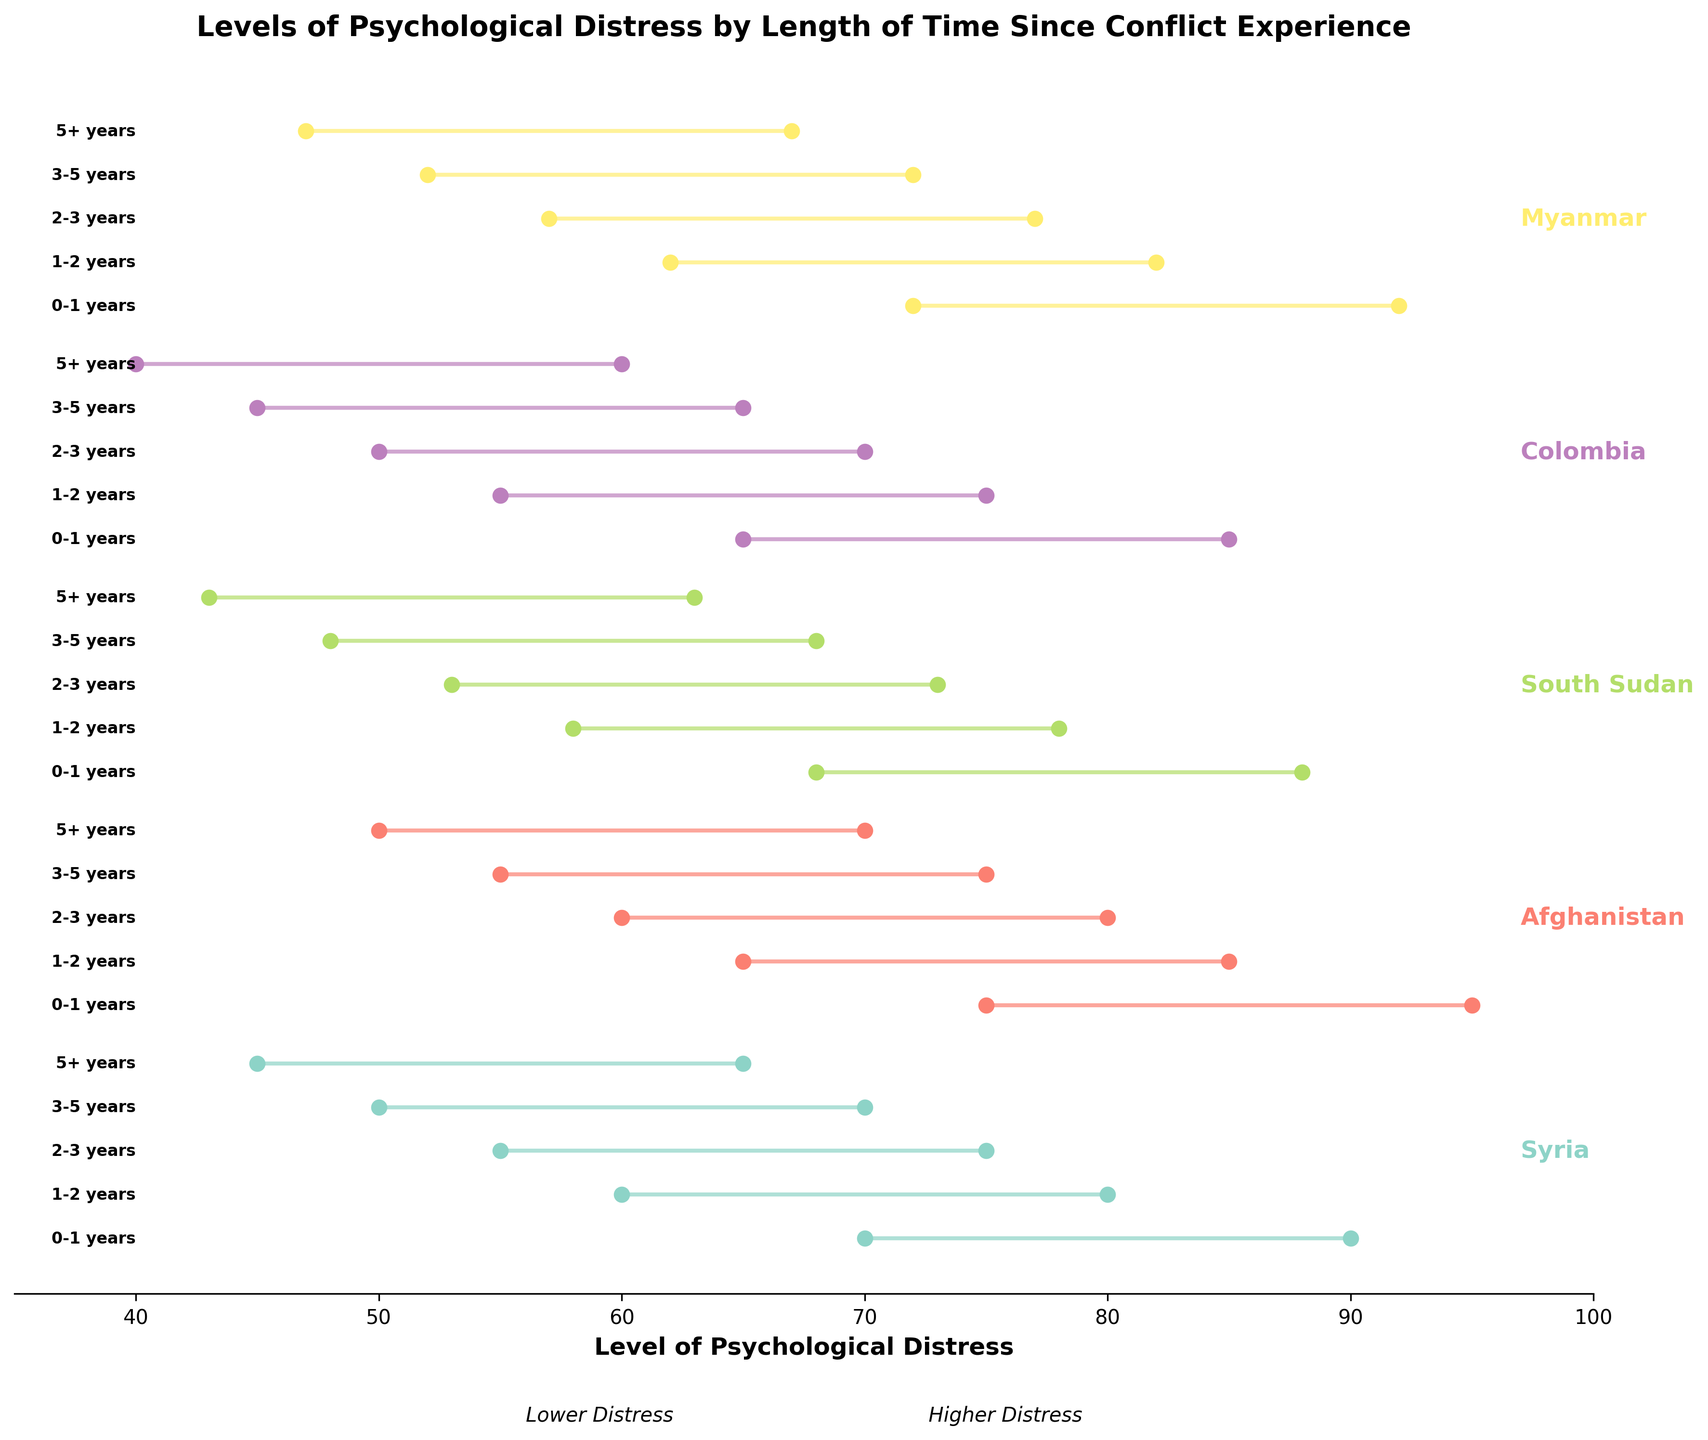Which group has the highest level of psychological distress in the first year after the conflict? In the range for the first year after the conflict, you need to evaluate the maximum distress values for all groups: Syria (90), Afghanistan (95), South Sudan (88), Colombia (85), and Myanmar (92). The highest maximum distress value is for Afghanistan.
Answer: Afghanistan How does the minimum level of psychological distress in Syria change from 0-1 years to 5+ years after the conflict? Look at the minimum distress values for Syria at 0-1 years (70) and 5+ years (45). Calculate the change by subtracting the two values: 70 - 45 = 25.
Answer: 25 Compare the range of psychological distress for Colombia from the first year after the conflict to 5+ years. Find the ranges for distress levels: 0-1 years (65 to 85) and 5+ years (40 to 60). The ranges are 85 - 65 = 20 and 60 - 40 = 20. The range remains the same.
Answer: The range remains the same Which group shows the smallest decrease in maximum psychological distress over time? Calculate the decrease in maximum distress from 0-1 years to 5+ years for all groups and find the smallest change: Syria (90 to 65, decrease 25), Afghanistan (95 to 70, decrease 25), South Sudan (88 to 63, decrease 25), Colombia (85 to 60, decrease 25), Myanmar (92 to 67, decrease 25). All have the same decrease.
Answer: All groups show the same decrease What is the average minimum distress level for Afghanistan after 3-5 years since the conflict? Look at the minimum distress values for Afghanistan for 3-5 years: 55 and 75. Calculate the average by summing them and dividing by 2: (55 + 75) / 2 = 65.
Answer: 65 How do the minimum and maximum distress levels in Myanmar compare between the second and fourth year after the conflict? Compare minimum and maximum distress values for Myanmar between 1-2 years and 3-5 years: 1-2 years (62 to 82), 3-5 years (52 to 72). The ranges are 82 - 62 = 20 and 72 - 52 = 20. Both ranges remain the same, but the values shift lower over time.
Answer: Values shift lower, range stays the same Which group has the lowest minimum distress value 5+ years after the conflict? Examine the minimum values for all groups at 5+ years: Syria (45), Afghanistan (50), South Sudan (43), Colombia (40), Myanmar (47). The lowest minimum distress value is for Colombia.
Answer: Colombia What is the difference between the maximum distress levels for South Sudan and Colombia in the first year after the conflict? Look at the maximum distress values for South Sudan (88) and Colombia (85) in the first year. Calculate the difference: 88 - 85 = 3.
Answer: 3 